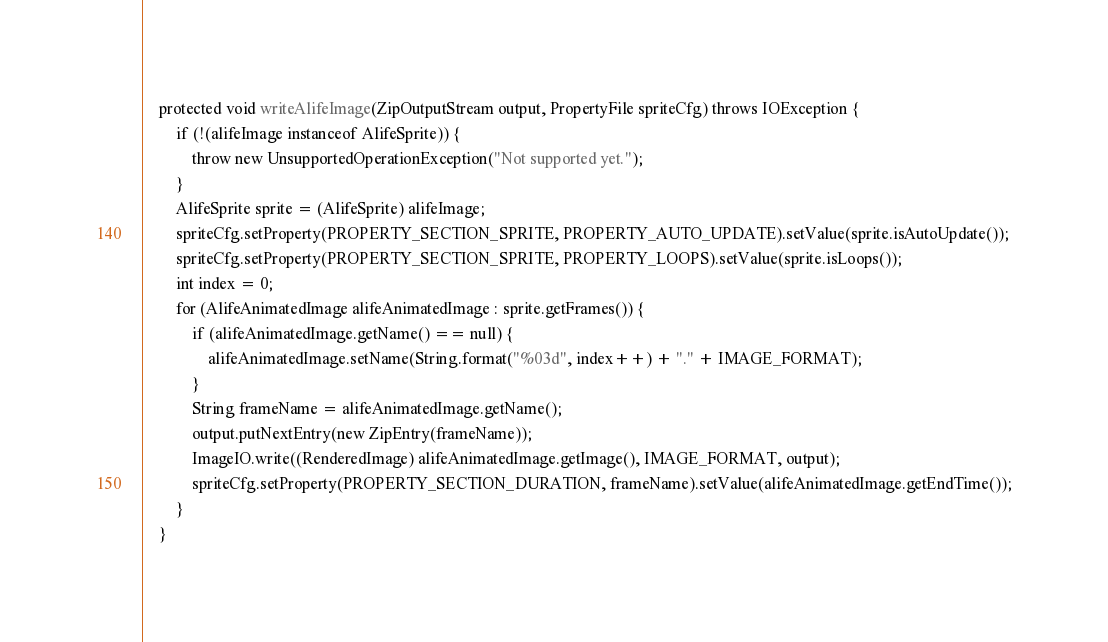Convert code to text. <code><loc_0><loc_0><loc_500><loc_500><_Java_>    protected void writeAlifeImage(ZipOutputStream output, PropertyFile spriteCfg) throws IOException {
        if (!(alifeImage instanceof AlifeSprite)) {
            throw new UnsupportedOperationException("Not supported yet.");
        }
        AlifeSprite sprite = (AlifeSprite) alifeImage;
        spriteCfg.setProperty(PROPERTY_SECTION_SPRITE, PROPERTY_AUTO_UPDATE).setValue(sprite.isAutoUpdate());
        spriteCfg.setProperty(PROPERTY_SECTION_SPRITE, PROPERTY_LOOPS).setValue(sprite.isLoops());
        int index = 0;
        for (AlifeAnimatedImage alifeAnimatedImage : sprite.getFrames()) {
            if (alifeAnimatedImage.getName() == null) {
                alifeAnimatedImage.setName(String.format("%03d", index++) + "." + IMAGE_FORMAT);
            }
            String frameName = alifeAnimatedImage.getName();
            output.putNextEntry(new ZipEntry(frameName));
            ImageIO.write((RenderedImage) alifeAnimatedImage.getImage(), IMAGE_FORMAT, output);
            spriteCfg.setProperty(PROPERTY_SECTION_DURATION, frameName).setValue(alifeAnimatedImage.getEndTime());
        }
    }
</code> 